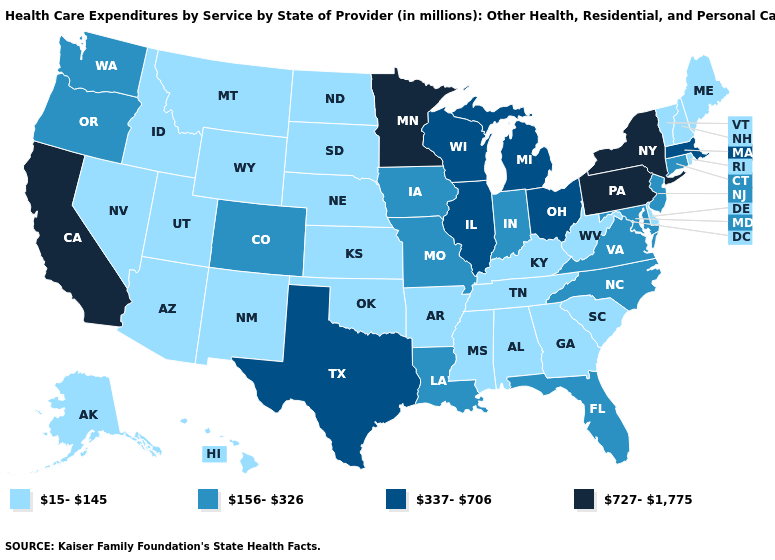Which states have the lowest value in the West?
Keep it brief. Alaska, Arizona, Hawaii, Idaho, Montana, Nevada, New Mexico, Utah, Wyoming. Name the states that have a value in the range 727-1,775?
Answer briefly. California, Minnesota, New York, Pennsylvania. What is the value of Wyoming?
Give a very brief answer. 15-145. What is the value of Massachusetts?
Give a very brief answer. 337-706. What is the value of Louisiana?
Keep it brief. 156-326. Does Pennsylvania have the highest value in the Northeast?
Quick response, please. Yes. Does West Virginia have a higher value than New Jersey?
Keep it brief. No. Name the states that have a value in the range 156-326?
Short answer required. Colorado, Connecticut, Florida, Indiana, Iowa, Louisiana, Maryland, Missouri, New Jersey, North Carolina, Oregon, Virginia, Washington. Name the states that have a value in the range 156-326?
Short answer required. Colorado, Connecticut, Florida, Indiana, Iowa, Louisiana, Maryland, Missouri, New Jersey, North Carolina, Oregon, Virginia, Washington. What is the highest value in states that border Maryland?
Answer briefly. 727-1,775. What is the value of Virginia?
Short answer required. 156-326. Among the states that border Iowa , which have the lowest value?
Short answer required. Nebraska, South Dakota. Which states hav the highest value in the MidWest?
Be succinct. Minnesota. Does Mississippi have the lowest value in the USA?
Concise answer only. Yes. 